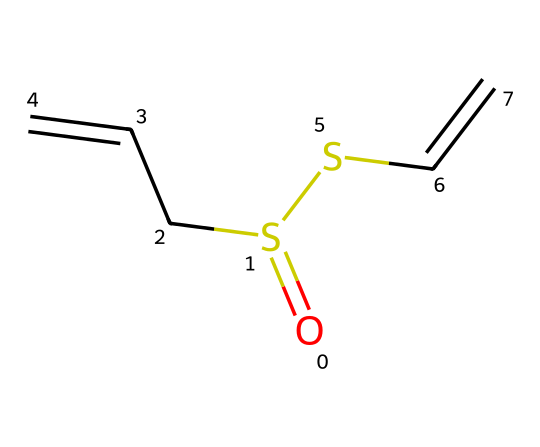What is the molecular formula of allicin based on its SMILES representation? By analyzing the SMILES notation O=S(CC=C)SC=C, we can identify the different atoms present. The notation indicates one sulfur atom (S) connected to an oxygen atom (O) by a double bond, two carbon atoms (C) in a chain (CC), and a carbon to another sulfur atom (SC) followed by a carbon-carbon double bond (C=C). Counting these atoms gives us: C = 6, H = 10, O = 1, S = 2. Therefore, the molecular formula is C6H10O1S2.
Answer: C6H10O2S2 How many carbon atoms are in the allicin structure? The SMILES representation contains the sequence CC, indicating two adjacent carbon atoms, and the two ends of the chain also have carbon atoms (C). Therefore, we can trace a total of six separate carbon atoms in the structure.
Answer: 6 What functional groups are present in allicin? In the structure represented by the SMILES, we have a sulfoxide functional group (O=S) and a thiol-like group (C-S) present due to the sulfur connectivity and functional groups. The double bonds indicate that it's an alkene, but the main focus here is on the sulfur-containing functionalities and their arrangement.
Answer: sulfoxide and thiol What type of chemical bond connects sulfur and oxygen in allicin? The presence of the notation O=S indicates that the sulfur receives a double bond from the oxygen. Double bonds are characterized by the sharing of two pairs of electrons between the connected atoms. Therefore, the bond connecting sulfur and oxygen in the allicin structure is a double bond.
Answer: double bond Is allicin considered a saturated or unsaturated compound? The presence of the double bonds (C=C) in the structure indicates that there are fewer hydrogen atoms than there would be in a fully saturated compound. As a result, allicin is categorized as an unsaturated compound due to these double bond placements, which typically signify unsaturation in organic molecules.
Answer: unsaturated What is the role of allicin in garlic's distinct odor? Allicin is known for generating the characteristic smell of garlic when garlic is crushed or chopped. This occurs as allicin quickly forms when the enzyme alliinase converts alliin (the inactive compound in garlic) to allicin amidst cellular damage. The presence of sulfur in allicin contributes to its potent odor.
Answer: distinct odor 